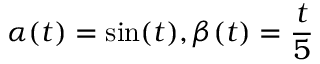Convert formula to latex. <formula><loc_0><loc_0><loc_500><loc_500>\alpha ( t ) = \sin ( t ) , \beta ( t ) = \frac { t } { 5 }</formula> 